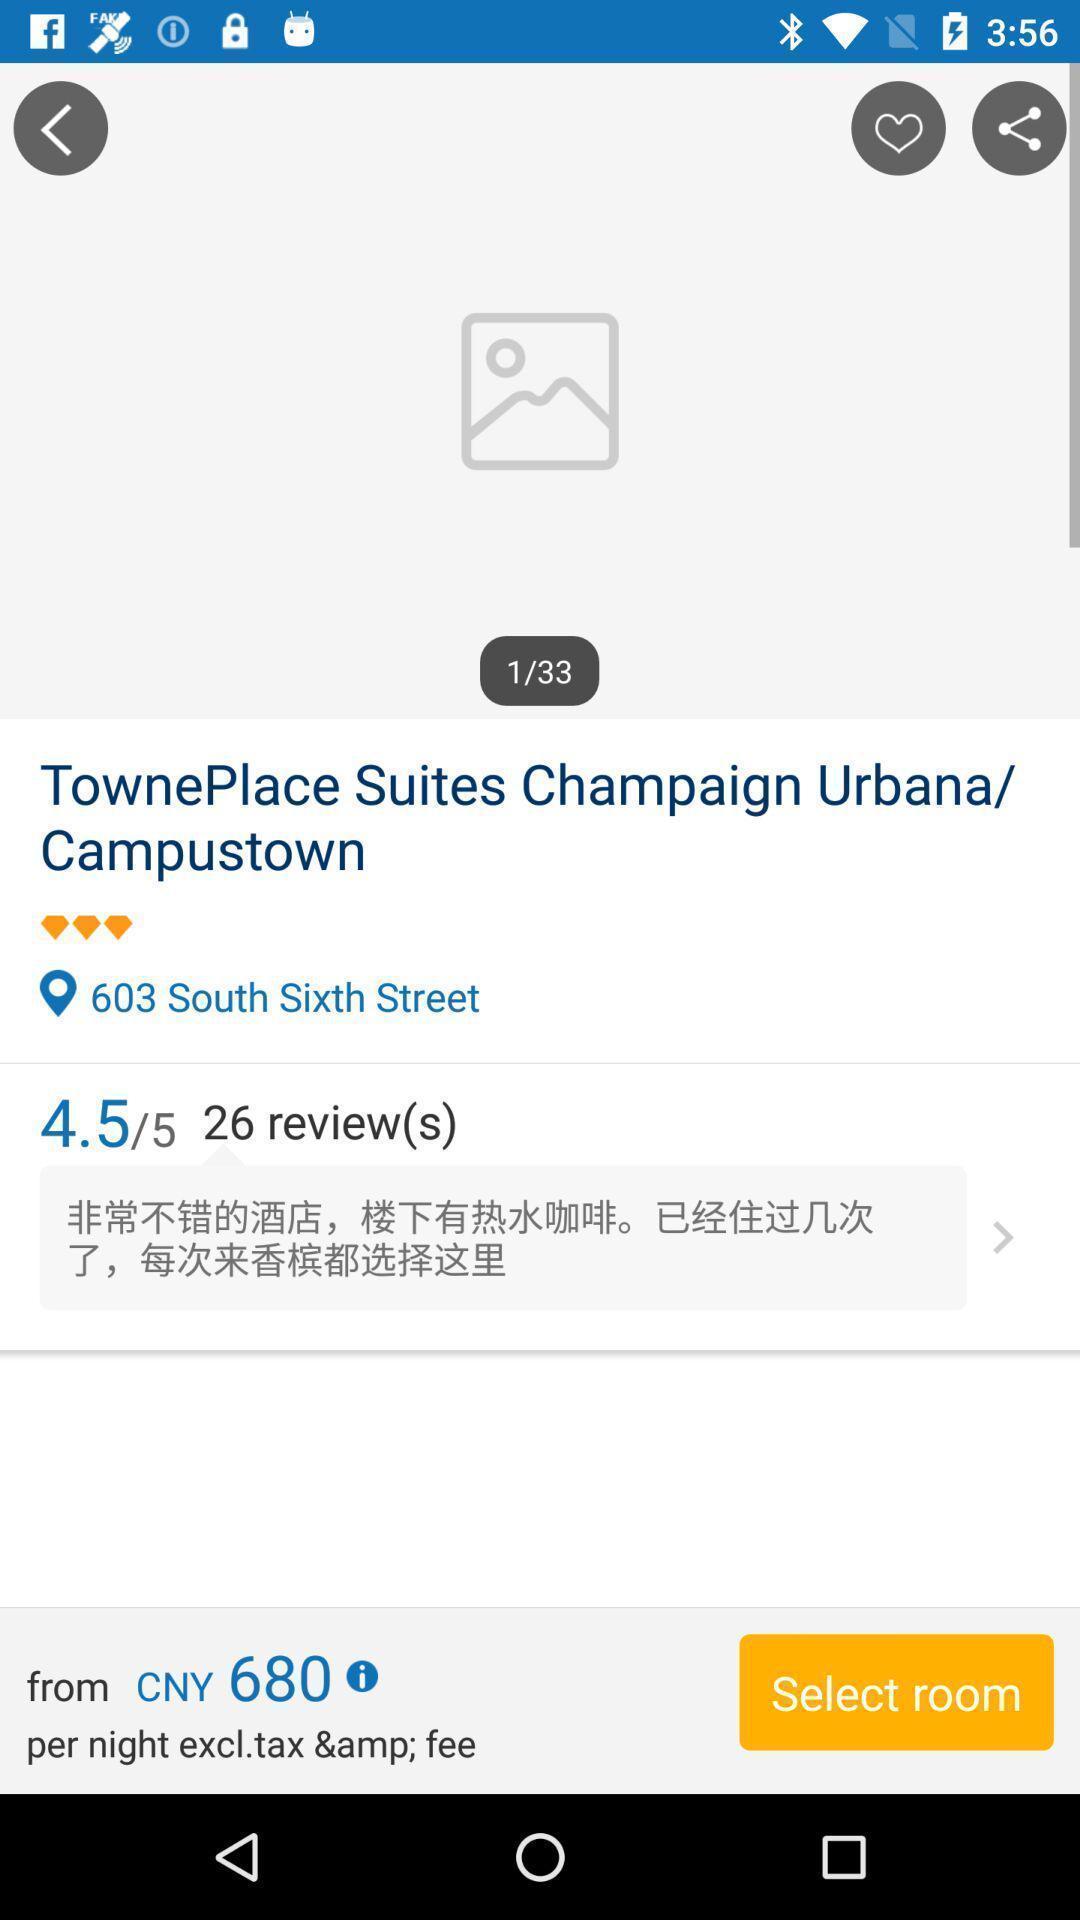What can you discern from this picture? Page for booking places of a booking app. 